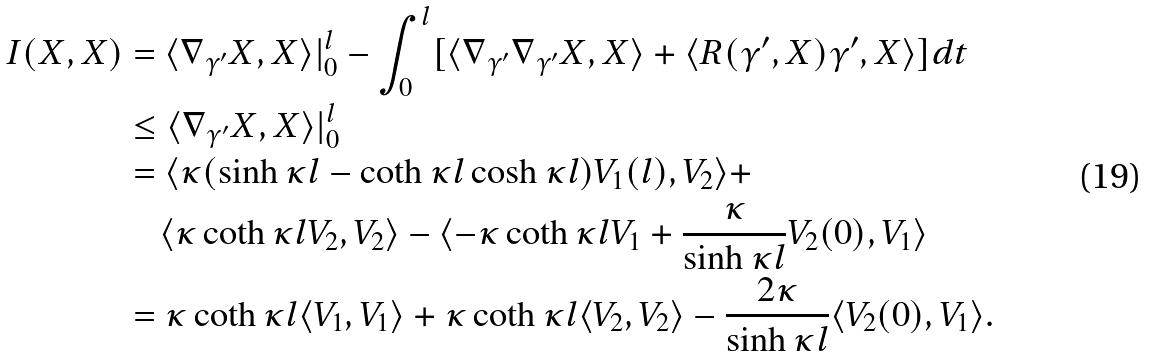Convert formula to latex. <formula><loc_0><loc_0><loc_500><loc_500>I ( X , X ) & = \langle \nabla _ { \gamma ^ { \prime } } X , X \rangle | _ { 0 } ^ { l } - \int _ { 0 } ^ { l } [ \langle \nabla _ { \gamma ^ { \prime } } \nabla _ { \gamma ^ { \prime } } X , X \rangle + \langle R ( \gamma ^ { \prime } , X ) \gamma ^ { \prime } , X \rangle ] d t \\ & \leq \langle \nabla _ { \gamma ^ { \prime } } X , X \rangle | _ { 0 } ^ { l } \\ & = \langle \kappa ( \sinh \kappa l - \coth \kappa l \cosh \kappa l ) V _ { 1 } ( l ) , V _ { 2 } \rangle + \\ & \quad \langle \kappa \coth \kappa l V _ { 2 } , V _ { 2 } \rangle - \langle - \kappa \coth \kappa l V _ { 1 } + \frac { \kappa } { \sinh \kappa l } V _ { 2 } ( 0 ) , V _ { 1 } \rangle \\ & = \kappa \coth \kappa l \langle V _ { 1 } , V _ { 1 } \rangle + \kappa \coth \kappa l \langle V _ { 2 } , V _ { 2 } \rangle - \frac { 2 \kappa } { \sinh \kappa l } \langle V _ { 2 } ( 0 ) , V _ { 1 } \rangle .</formula> 